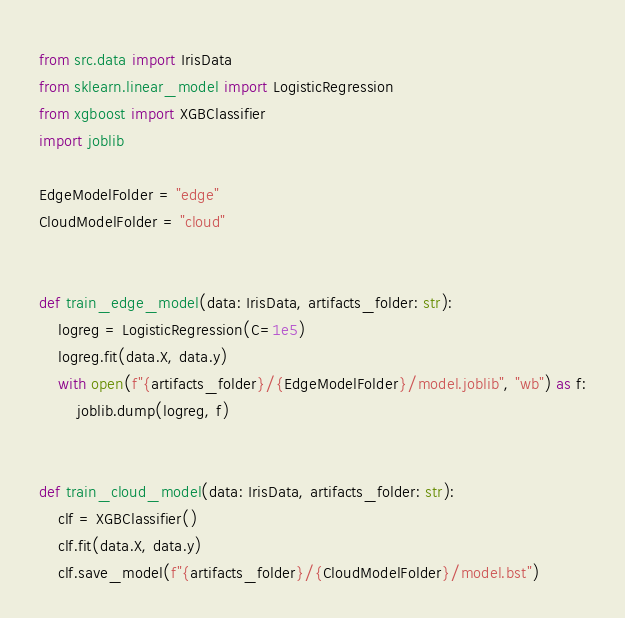Convert code to text. <code><loc_0><loc_0><loc_500><loc_500><_Python_>from src.data import IrisData
from sklearn.linear_model import LogisticRegression
from xgboost import XGBClassifier
import joblib

EdgeModelFolder = "edge"
CloudModelFolder = "cloud"


def train_edge_model(data: IrisData, artifacts_folder: str):
    logreg = LogisticRegression(C=1e5)
    logreg.fit(data.X, data.y)
    with open(f"{artifacts_folder}/{EdgeModelFolder}/model.joblib", "wb") as f:
        joblib.dump(logreg, f)


def train_cloud_model(data: IrisData, artifacts_folder: str):
    clf = XGBClassifier()
    clf.fit(data.X, data.y)
    clf.save_model(f"{artifacts_folder}/{CloudModelFolder}/model.bst")
</code> 